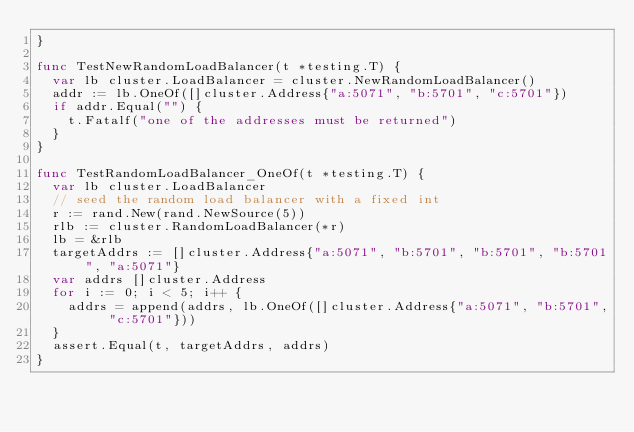<code> <loc_0><loc_0><loc_500><loc_500><_Go_>}

func TestNewRandomLoadBalancer(t *testing.T) {
	var lb cluster.LoadBalancer = cluster.NewRandomLoadBalancer()
	addr := lb.OneOf([]cluster.Address{"a:5071", "b:5701", "c:5701"})
	if addr.Equal("") {
		t.Fatalf("one of the addresses must be returned")
	}
}

func TestRandomLoadBalancer_OneOf(t *testing.T) {
	var lb cluster.LoadBalancer
	// seed the random load balancer with a fixed int
	r := rand.New(rand.NewSource(5))
	rlb := cluster.RandomLoadBalancer(*r)
	lb = &rlb
	targetAddrs := []cluster.Address{"a:5071", "b:5701", "b:5701", "b:5701", "a:5071"}
	var addrs []cluster.Address
	for i := 0; i < 5; i++ {
		addrs = append(addrs, lb.OneOf([]cluster.Address{"a:5071", "b:5701", "c:5701"}))
	}
	assert.Equal(t, targetAddrs, addrs)
}
</code> 